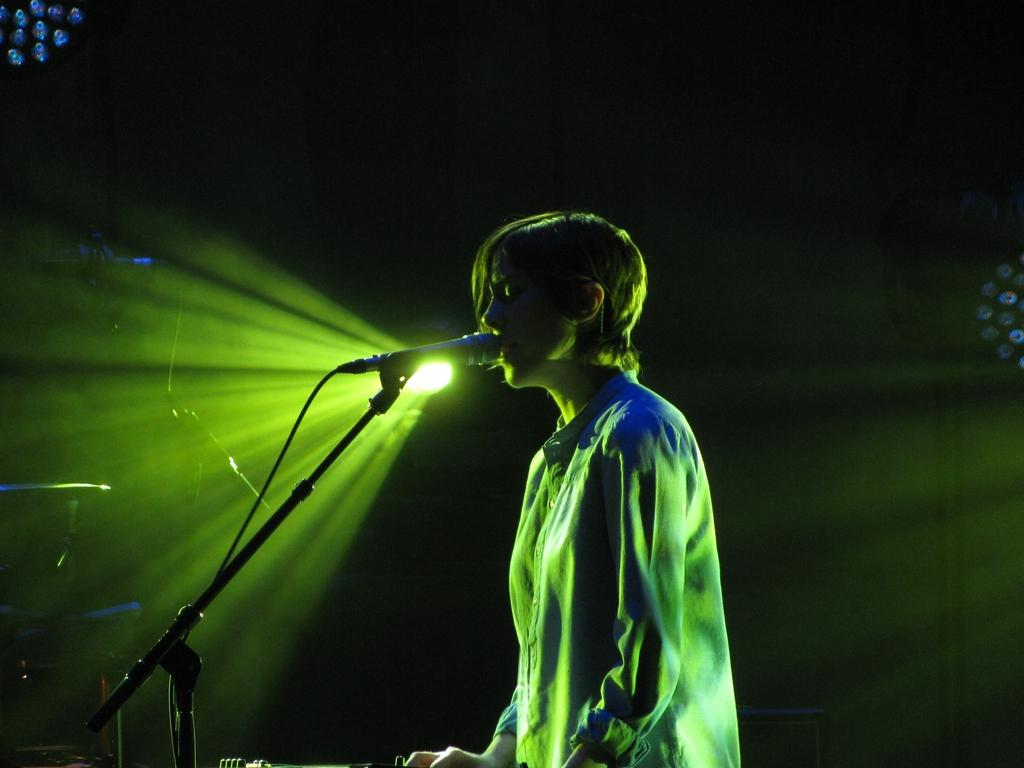What is the main subject of the image? There is a person standing in the image. What object is the person using or interacting with? There is a microphone with a microphone stand in the image. What type of lighting can be seen in the background of the image? There are focus lights in the background of the image. What else can be seen in the background of the image? There are other objects visible in the background. Where is the playground located in the image? There is no playground present in the image. What type of pump is being used by the person in the image? There is no pump visible in the image; the person is interacting with a microphone and microphone stand. 